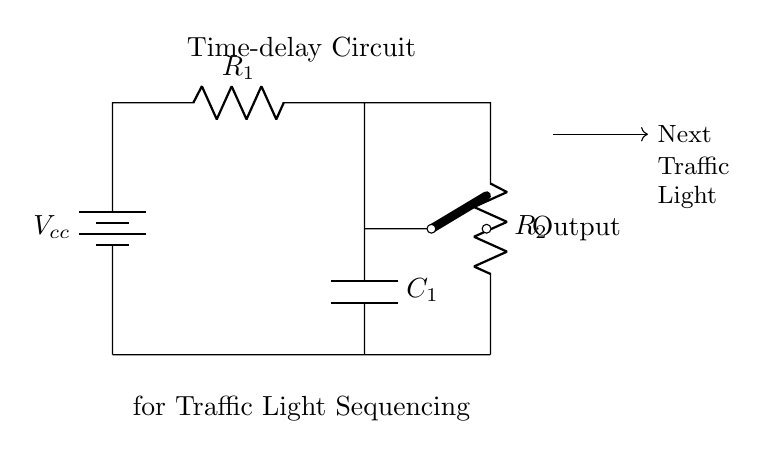What is the value of R1 in the circuit? The circuit diagram labels R1, but the specific resistance value is not indicated. Therefore, one would need to refer to a design document or specifications that detail the resistance values.
Answer: Not specified What is the purpose of capacitor C1? The capacitor C1 in the time-delay circuit is used to store charge and release it, which creates a delay in the traffic light sequencing. This delay is a crucial factor in ensuring that the traffic lights operate smoothly, allowing the necessary time for vehicles and pedestrians to clear intersections.
Answer: Time delay Which component controls the delay timing in this circuit? In an RC (resistor-capacitor) circuit, the timing delay is primarily determined by the values of the resistor and capacitor. The product of resistance and capacitance (RC) gives the time constant, which directly influences how long it takes for the capacitor to charge or discharge through the resistor.
Answer: R1 and C1 What can be inferred about the output in this circuit? The output connection in the circuit, situated after the switch, indicates the point where the output signal will initiate the next step in the traffic light sequencing process once the capacitor charges through the resistor-paired elements.
Answer: Next traffic light What type of switch is used in this circuit? The circuit employs a cute open switch, meaning it can either be in the 'on' or 'off' position to control the flow of electricity, impacting when the traffic light changes based on the capacitor's charge.
Answer: Cute open switch How does the configuration of R1 and R2 affect the time delay? The configuration of R1 and R2 in the circuit determines the total resistance in series, which in conjunction with the value of C1 affects the time constant, thus influencing how much time is allowed before the traffic light changes. A higher resistance leads to a longer charging time of the capacitor, while a lower resistance leads to a quicker change.
Answer: Total resistance impacts timing 